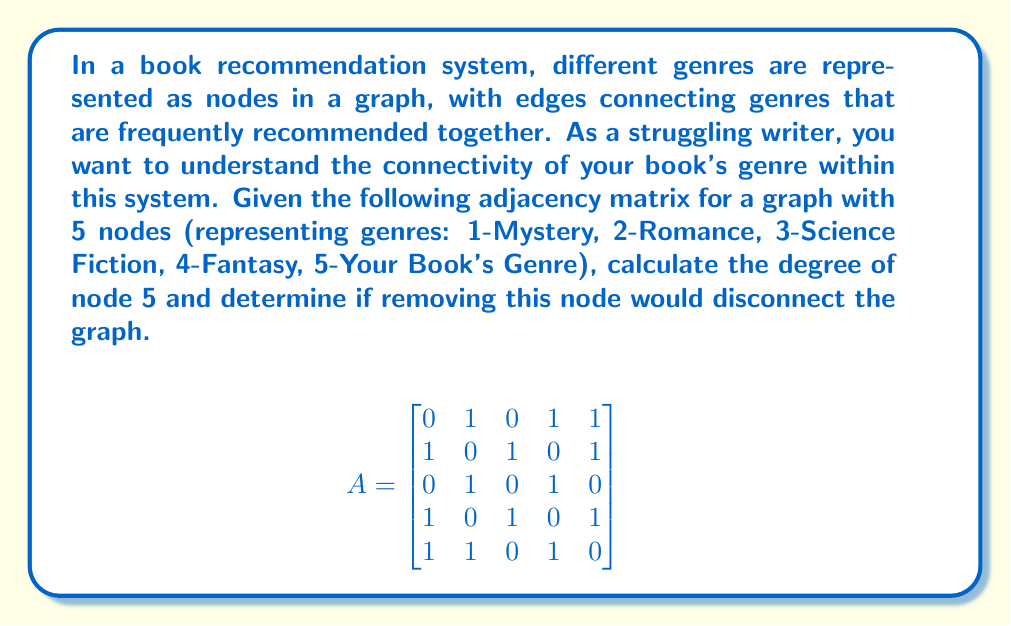Can you answer this question? To solve this problem, we need to follow these steps:

1. Calculate the degree of node 5 (Your Book's Genre):
   The degree of a node is the number of edges connected to it. In an adjacency matrix, this is equal to the sum of the corresponding row (or column, as the matrix is symmetric).

   For node 5: $1 + 1 + 0 + 1 + 0 = 3$

2. Determine if removing node 5 would disconnect the graph:
   To do this, we need to check if the remaining subgraph (after removing node 5 and its edges) is still connected.

   a) Remove row 5 and column 5 from the adjacency matrix:
   $$
   A' = \begin{bmatrix}
   0 & 1 & 0 & 1 \\
   1 & 0 & 1 & 0 \\
   0 & 1 & 0 & 1 \\
   1 & 0 & 1 & 0
   \end{bmatrix}
   $$

   b) Check if this subgraph is connected:
      - A graph is connected if there's a path between any two nodes.
      - We can check this by calculating $(A' + I)^n$, where $n$ is the number of nodes (4 in this case) and $I$ is the identity matrix.
      - If any element in $(A' + I)^4$ is zero, the graph is disconnected.

   $$
   (A' + I)^4 = \begin{bmatrix}
   25 & 16 & 16 & 16 \\
   16 & 25 & 16 & 16 \\
   16 & 16 & 25 & 16 \\
   16 & 16 & 16 & 25
   \end{bmatrix}
   $$

   Since there are no zero elements, the subgraph remains connected after removing node 5.
Answer: The degree of node 5 is 3. Removing node 5 would not disconnect the graph. 